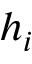<formula> <loc_0><loc_0><loc_500><loc_500>h _ { i }</formula> 